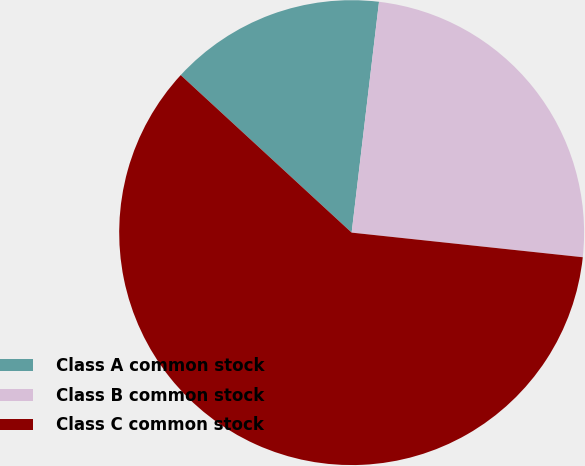Convert chart. <chart><loc_0><loc_0><loc_500><loc_500><pie_chart><fcel>Class A common stock<fcel>Class B common stock<fcel>Class C common stock<nl><fcel>15.03%<fcel>24.81%<fcel>60.16%<nl></chart> 